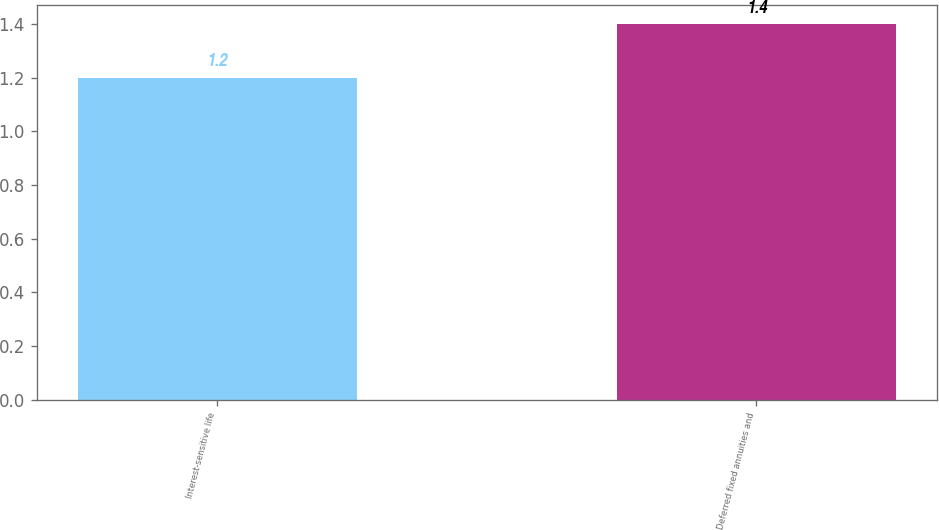Convert chart. <chart><loc_0><loc_0><loc_500><loc_500><bar_chart><fcel>Interest-sensitive life<fcel>Deferred fixed annuities and<nl><fcel>1.2<fcel>1.4<nl></chart> 